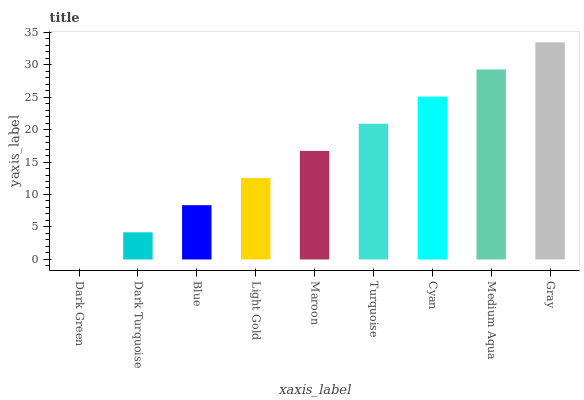Is Dark Turquoise the minimum?
Answer yes or no. No. Is Dark Turquoise the maximum?
Answer yes or no. No. Is Dark Turquoise greater than Dark Green?
Answer yes or no. Yes. Is Dark Green less than Dark Turquoise?
Answer yes or no. Yes. Is Dark Green greater than Dark Turquoise?
Answer yes or no. No. Is Dark Turquoise less than Dark Green?
Answer yes or no. No. Is Maroon the high median?
Answer yes or no. Yes. Is Maroon the low median?
Answer yes or no. Yes. Is Dark Green the high median?
Answer yes or no. No. Is Dark Turquoise the low median?
Answer yes or no. No. 